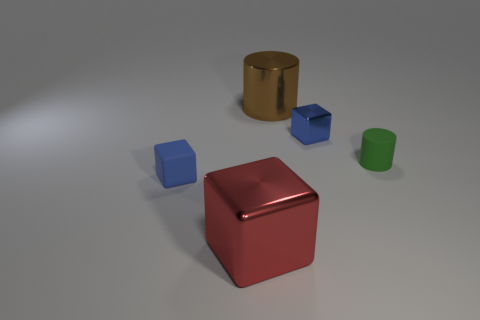Can you tell me how many objects are there and what colors they are? In the image, there are five objects. There is a large red cube, a smaller blue cube, an even smaller light blue cube, a shiny gold cylinder, and a green cylinder. 